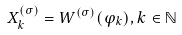<formula> <loc_0><loc_0><loc_500><loc_500>X _ { k } ^ { ( \sigma ) } = W ^ { ( \sigma ) } ( \varphi _ { k } ) , k \in \mathbb { N }</formula> 